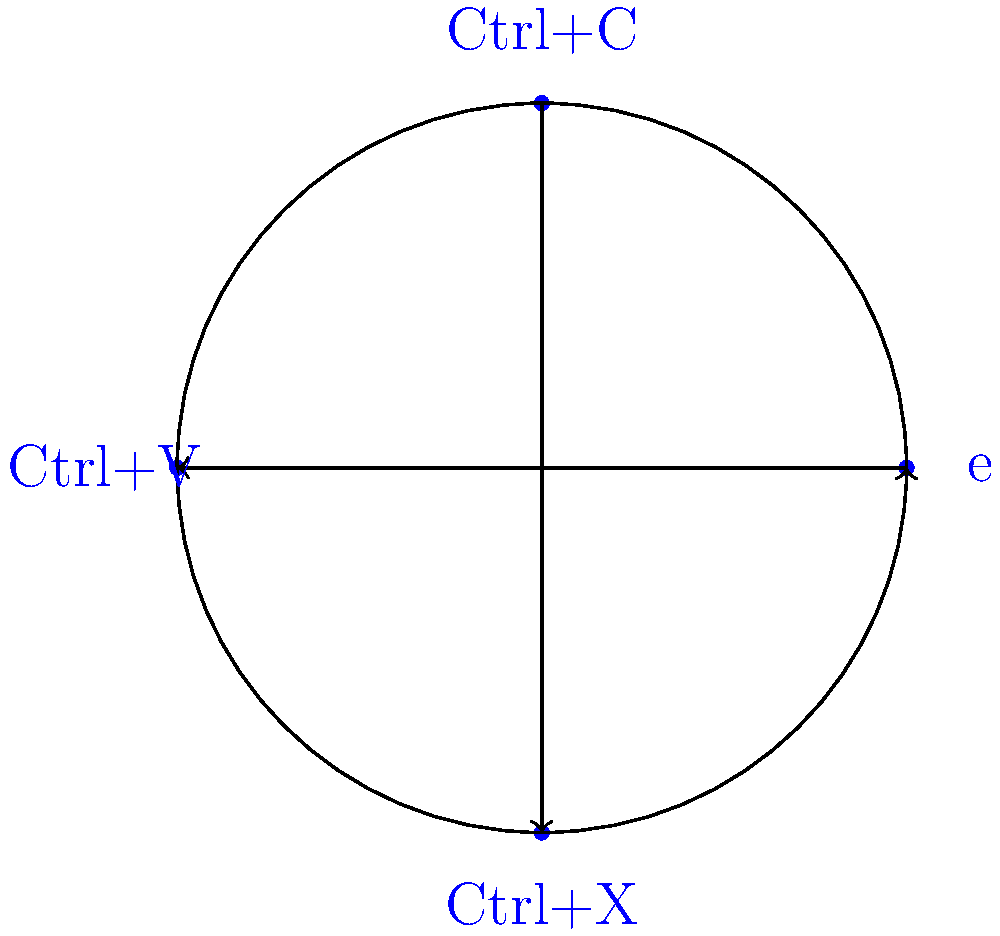In a keyboard shortcut system, consider the group $G = \{e, \text{Ctrl+C}, \text{Ctrl+V}, \text{Ctrl+X}\}$ under the operation of sequential execution. The identity element is $e$, representing no action. How many distinct cyclic subgroups does this group contain, and what is the order of the largest cyclic subgroup? Let's approach this step-by-step:

1) First, we need to understand the group structure:
   - $e$ is the identity element
   - $(\text{Ctrl+C})^2 = e$, $(\text{Ctrl+V})^2 = e$, $(\text{Ctrl+X})^2 = e$

2) Now, let's identify all cyclic subgroups:

   a) $\langle e \rangle = \{e\}$, order 1
   b) $\langle \text{Ctrl+C} \rangle = \{e, \text{Ctrl+C}\}$, order 2
   c) $\langle \text{Ctrl+V} \rangle = \{e, \text{Ctrl+V}\}$, order 2
   d) $\langle \text{Ctrl+X} \rangle = \{e, \text{Ctrl+X}\}$, order 2

3) Count the distinct cyclic subgroups:
   There are 4 distinct cyclic subgroups.

4) Identify the largest cyclic subgroup:
   The largest cyclic subgroups are of order 2.

Therefore, there are 4 distinct cyclic subgroups, and the order of the largest cyclic subgroup is 2.
Answer: 4 distinct cyclic subgroups; largest order is 2 